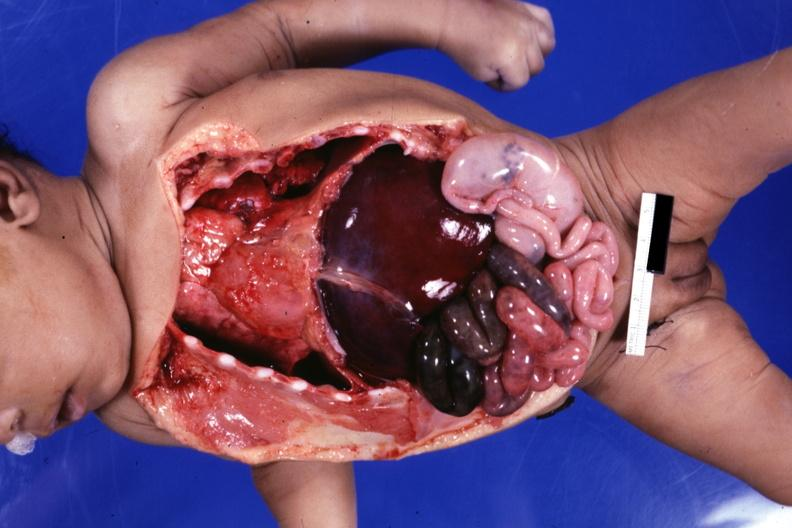s infant body opened showing cardiac apex to right, right liver lobe on left cecum on left gangrenous small bowel?
Answer the question using a single word or phrase. Yes 